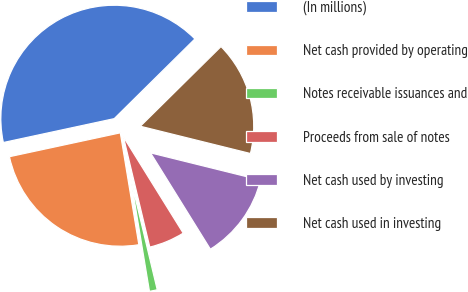Convert chart. <chart><loc_0><loc_0><loc_500><loc_500><pie_chart><fcel>(In millions)<fcel>Net cash provided by operating<fcel>Notes receivable issuances and<fcel>Proceeds from sale of notes<fcel>Net cash used by investing<fcel>Net cash used in investing<nl><fcel>40.97%<fcel>24.24%<fcel>1.12%<fcel>5.11%<fcel>12.29%<fcel>16.27%<nl></chart> 